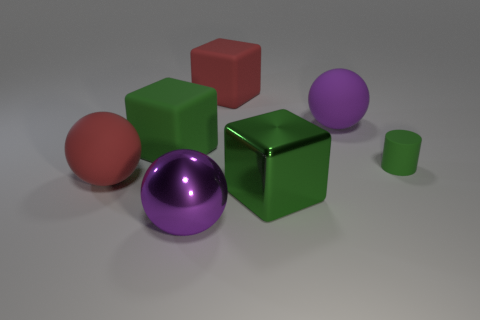What size is the red object that is on the right side of the thing in front of the green metallic block?
Ensure brevity in your answer.  Large. What is the shape of the green thing that is in front of the red rubber thing on the left side of the green rubber thing that is left of the big metallic sphere?
Your response must be concise. Cube. The green cylinder that is made of the same material as the red cube is what size?
Your answer should be compact. Small. Are there more matte cubes than large metal blocks?
Provide a short and direct response. Yes. There is a green cube that is the same size as the green shiny thing; what is its material?
Keep it short and to the point. Rubber. There is a purple ball that is in front of the green rubber cylinder; is its size the same as the big purple rubber object?
Provide a short and direct response. Yes. How many cylinders are cyan shiny objects or purple metal things?
Your answer should be compact. 0. What is the material of the purple ball that is behind the cylinder?
Make the answer very short. Rubber. Are there fewer spheres than small green matte objects?
Give a very brief answer. No. There is a cube that is to the right of the big green matte block and in front of the large red cube; what is its size?
Your answer should be very brief. Large. 